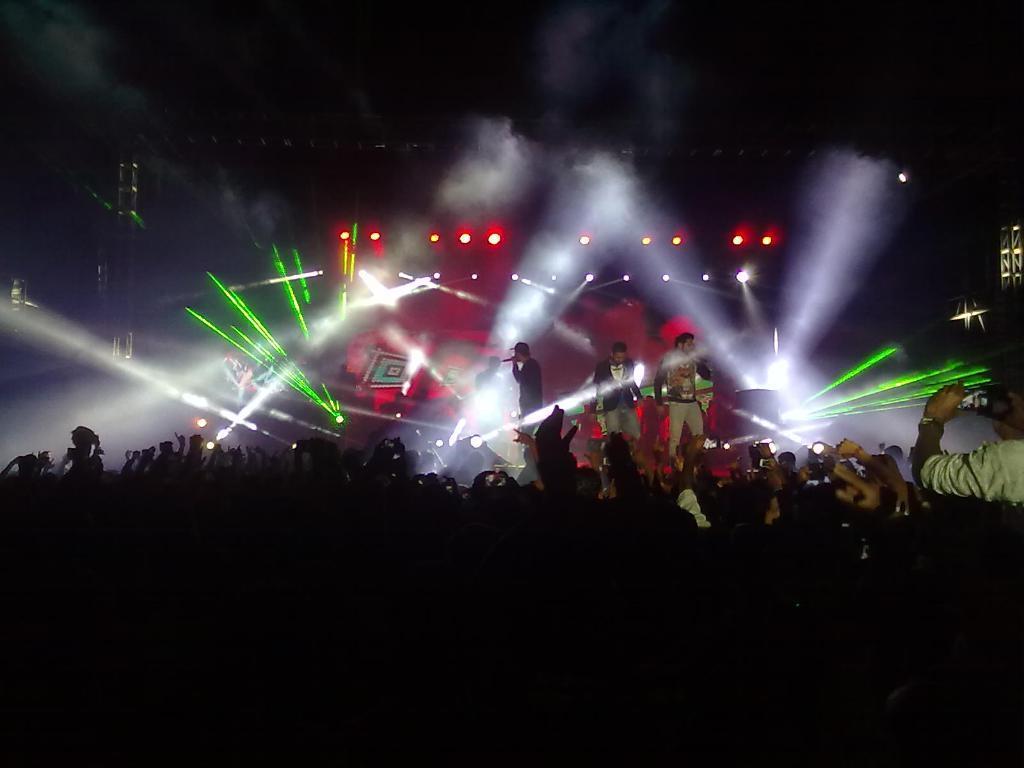Could you give a brief overview of what you see in this image? In this image I can see group of people. In the background I can see two persons standing and holding two microphones and I can also see the person playing the musical instrument and few lights. 